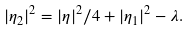<formula> <loc_0><loc_0><loc_500><loc_500>| \eta _ { 2 } | ^ { 2 } = | \eta | ^ { 2 } / 4 + | \eta _ { 1 } | ^ { 2 } - \lambda .</formula> 